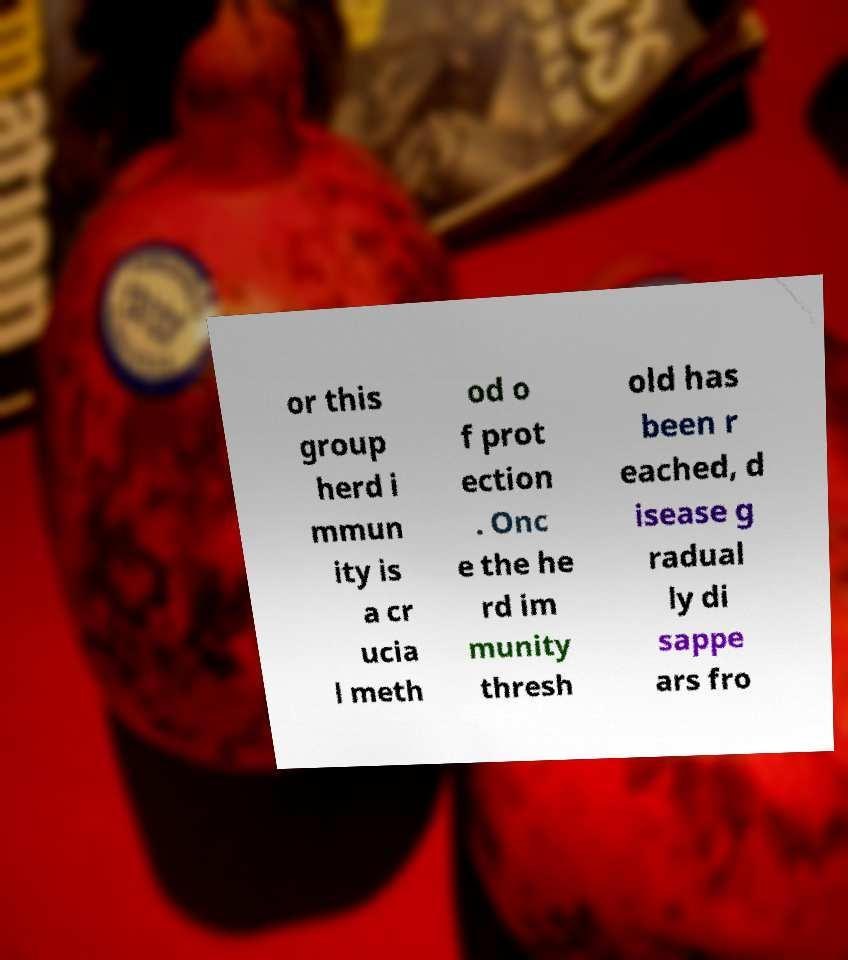Could you assist in decoding the text presented in this image and type it out clearly? or this group herd i mmun ity is a cr ucia l meth od o f prot ection . Onc e the he rd im munity thresh old has been r eached, d isease g radual ly di sappe ars fro 